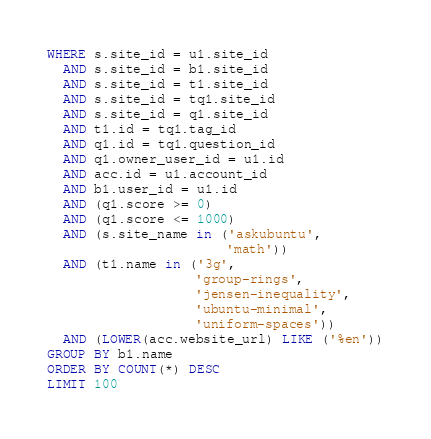Convert code to text. <code><loc_0><loc_0><loc_500><loc_500><_SQL_>WHERE s.site_id = u1.site_id
  AND s.site_id = b1.site_id
  AND s.site_id = t1.site_id
  AND s.site_id = tq1.site_id
  AND s.site_id = q1.site_id
  AND t1.id = tq1.tag_id
  AND q1.id = tq1.question_id
  AND q1.owner_user_id = u1.id
  AND acc.id = u1.account_id
  AND b1.user_id = u1.id
  AND (q1.score >= 0)
  AND (q1.score <= 1000)
  AND (s.site_name in ('askubuntu',
                       'math'))
  AND (t1.name in ('3g',
                   'group-rings',
                   'jensen-inequality',
                   'ubuntu-minimal',
                   'uniform-spaces'))
  AND (LOWER(acc.website_url) LIKE ('%en'))
GROUP BY b1.name
ORDER BY COUNT(*) DESC
LIMIT 100</code> 